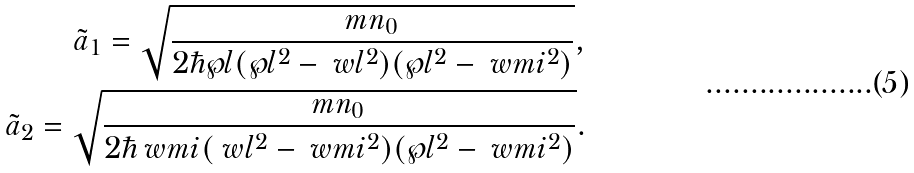Convert formula to latex. <formula><loc_0><loc_0><loc_500><loc_500>\tilde { a } _ { 1 } = \sqrt { \frac { m n _ { 0 } } { 2 \hbar { \wp } l ( \wp l ^ { 2 } - \ w l ^ { 2 } ) ( \wp l ^ { 2 } - \ w m i ^ { 2 } ) } } , \\ \tilde { a } _ { 2 } = \sqrt { \frac { m n _ { 0 } } { 2 \hbar { \ } w m i ( \ w l ^ { 2 } - \ w m i ^ { 2 } ) ( \wp l ^ { 2 } - \ w m i ^ { 2 } ) } } .</formula> 